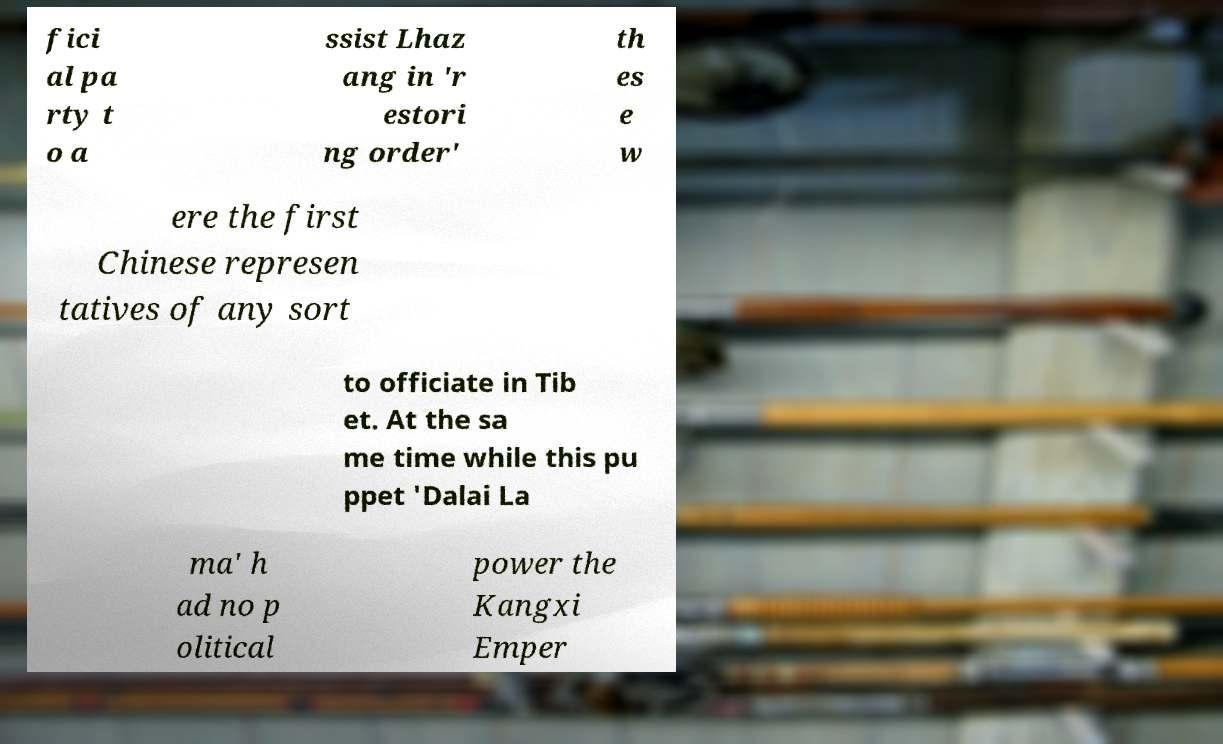What messages or text are displayed in this image? I need them in a readable, typed format. fici al pa rty t o a ssist Lhaz ang in 'r estori ng order' th es e w ere the first Chinese represen tatives of any sort to officiate in Tib et. At the sa me time while this pu ppet 'Dalai La ma' h ad no p olitical power the Kangxi Emper 